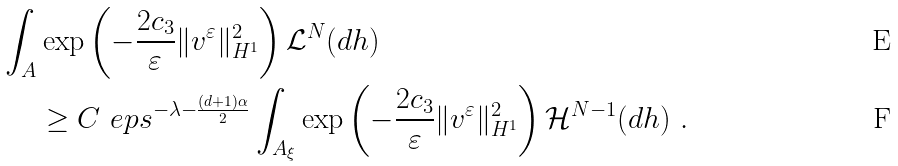Convert formula to latex. <formula><loc_0><loc_0><loc_500><loc_500>\int _ { A } & \exp \left ( - \frac { 2 c _ { 3 } } { \varepsilon } \| v ^ { \varepsilon } \| _ { H ^ { 1 } } ^ { 2 } \right ) \mathcal { L } ^ { N } ( d h ) \\ & \geq C \ e p s ^ { - \lambda - \frac { ( d + 1 ) \alpha } { 2 } } \int _ { A _ { \xi } } \exp \left ( - \frac { 2 c _ { 3 } } { \varepsilon } \| v ^ { \varepsilon } \| _ { H ^ { 1 } } ^ { 2 } \right ) \mathcal { H } ^ { N - 1 } ( d h ) \ .</formula> 